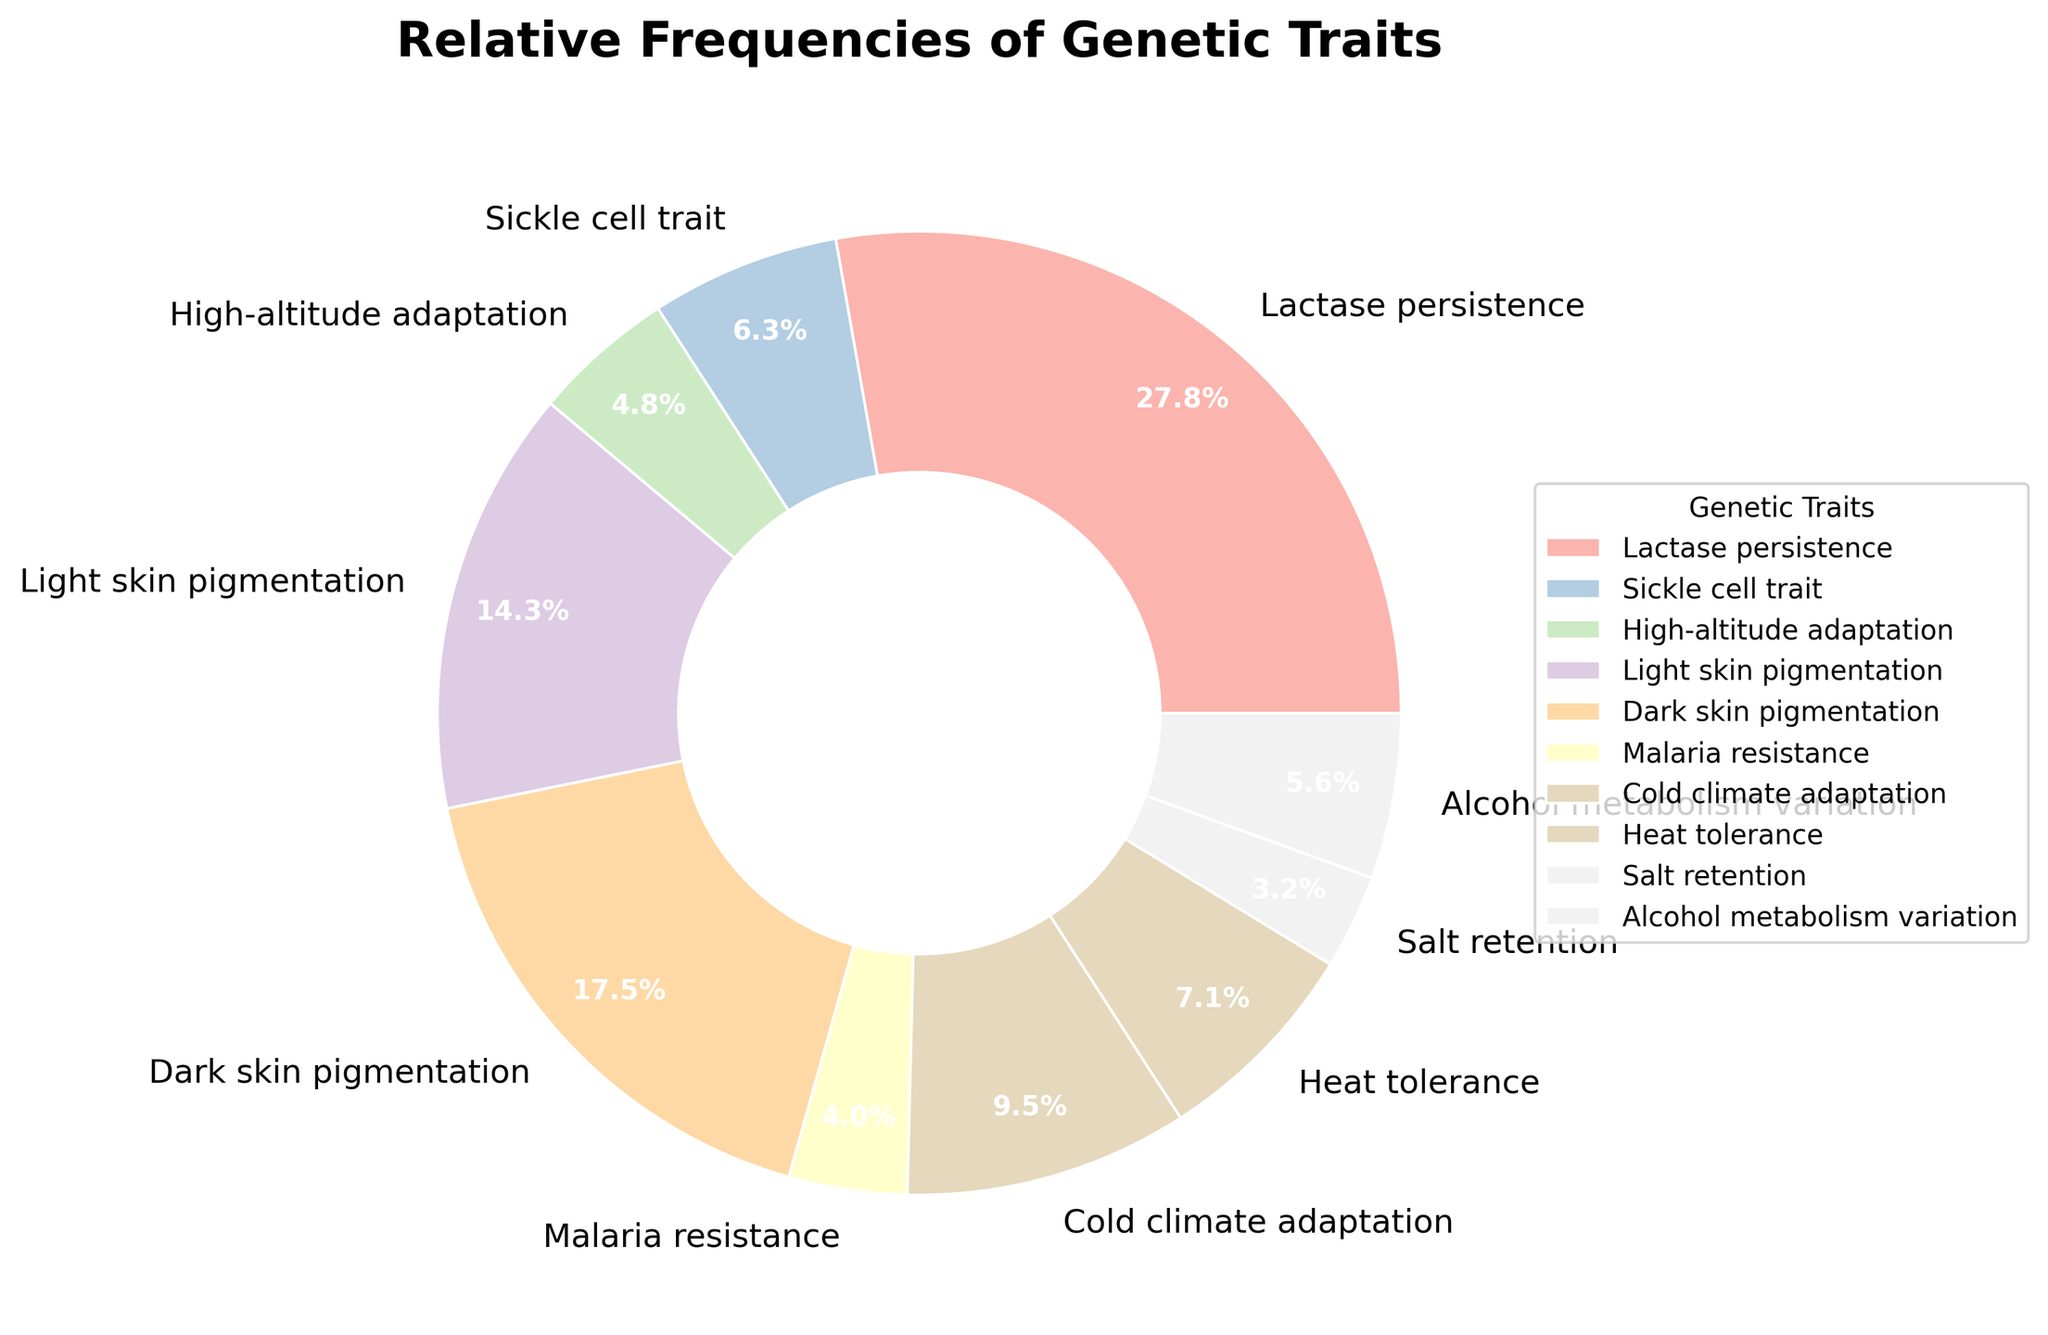Which genetic trait has the highest relative frequency? To find the genetic trait with the highest relative frequency, look for the largest segment in the pie chart. The segment labeled "Lactase persistence" occupies the largest portion of the pie chart.
Answer: Lactase persistence Which two genetic traits have the lowest relative frequencies, and what are their combined frequencies? Identify the two smallest segments in the pie chart. These segments correspond to "Salt retention" and "Malaria resistance," each with smaller portions. Their frequencies are 0.04 and 0.05, respectively. Add the two values: 0.04 + 0.05 = 0.09.
Answer: Salt retention, Malaria resistance, 0.09 What is the combined relative frequency of skin pigmentation-related traits? Identify the segments related to skin pigmentation: "Light skin pigmentation" and "Dark skin pigmentation." Their frequencies are 0.18 and 0.22, respectively. Add these two values: 0.18 + 0.22 = 0.4.
Answer: 0.4 Which trait has a higher relative frequency: "Heat tolerance" or "High-altitude adaptation"? Compare the segments labeled "Heat tolerance" and "High-altitude adaptation." The segment for "Heat tolerance" is slightly larger. Their respective frequencies are 0.09 and 0.06.
Answer: Heat tolerance What is the difference in frequency between "Cold climate adaptation" and "Sickle cell trait"? Find the segments labeled "Cold climate adaptation" and "Sickle cell trait" and note their frequencies: 0.12 and 0.08, respectively. Subtract the smaller value from the larger one: 0.12 - 0.08 = 0.04.
Answer: 0.04 What is the relative frequency of "Lactase persistence" compared to the combined frequency of "Cold climate adaptation" and "Alcohol metabolism variation"? Note the frequency of "Lactase persistence" (0.35) and the frequencies of "Cold climate adaptation" and "Alcohol metabolism variation," which are 0.12 and 0.07, respectively. Add the two frequencies: 0.12 + 0.07 = 0.19. Compare this sum to 0.35.
Answer: 0.35 is higher What is the percentage difference between "Light skin pigmentation" and "Dark skin pigmentation"? Note the percentages for "Light skin pigmentation" (18%) and "Dark skin pigmentation" (22%). Subtract the smaller percentage from the larger: 22% - 18% = 4%.
Answer: 4% Which genetic traits have frequencies between 0.05 and 0.10? Locate the segments with frequencies within the range 0.05 to 0.10. These are "Sickle cell trait" (0.08), "Malaria resistance" (0.05), "Heat tolerance" (0.09), and "Alcohol metabolism variation" (0.07).
Answer: Sickle cell trait, Malaria resistance, Heat tolerance, Alcohol metabolism variation Is the frequency of "Dark skin pigmentation" more than twice the frequency of "Sickle cell trait"? Note the frequencies: "Dark skin pigmentation" is 0.22, and "Sickle cell trait" is 0.08. Calculate twice the frequency of "Sickle cell trait": 2 * 0.08 = 0.16. Compare this to 0.22.
Answer: Yes What proportion of the traits have a frequency greater than 0.1? Count the segments with frequencies greater than 0.1: "Lactase persistence" (0.35), "Light skin pigmentation" (0.18), "Dark skin pigmentation" (0.22), and "Cold climate adaptation" (0.12). There are 4 of them out of 10 traits. The proportion is 4/10.
Answer: 0.4 